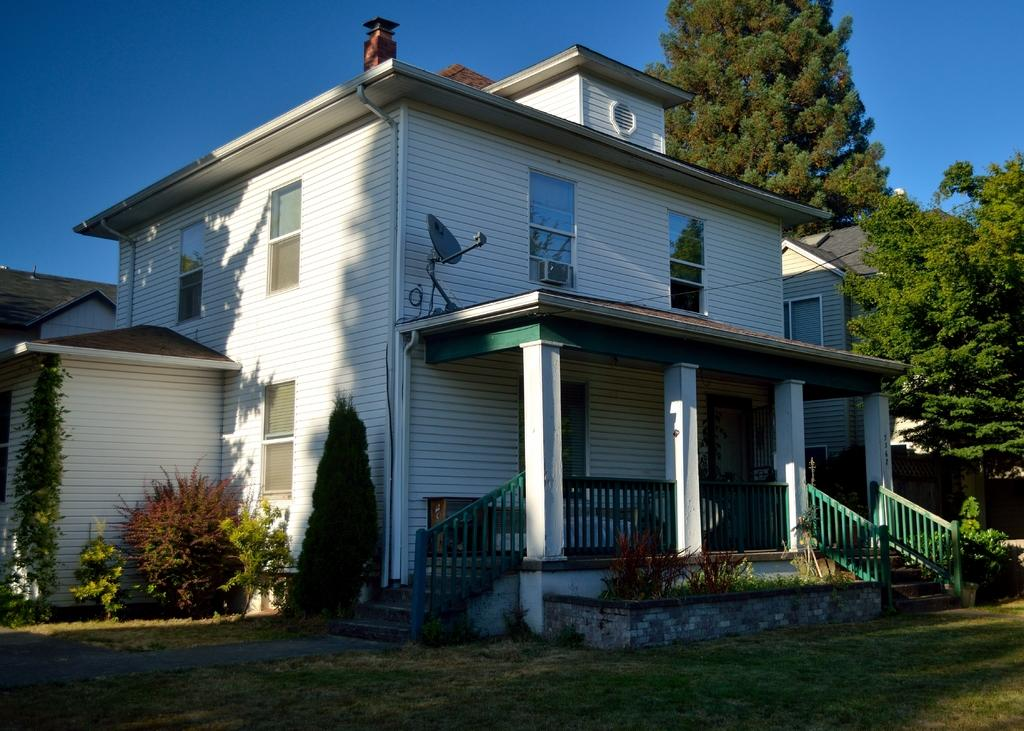What type of vegetation can be seen in the image? There are plants, trees, and grass visible in the image. What type of structure is present in the image? There are houses in the image. What is the purpose of the fence in the image? The fence in the image serves as a boundary or barrier. What can be seen in the background of the image? The sky is visible in the background of the image. How many trucks are parked near the cemetery in the image? There is no cemetery or trucks present in the image. 